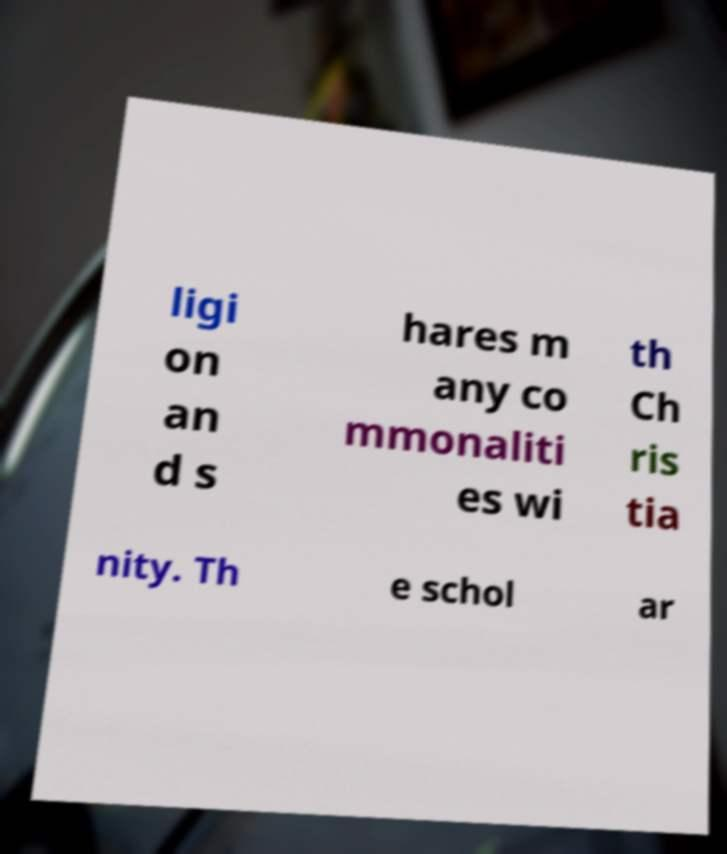Can you accurately transcribe the text from the provided image for me? ligi on an d s hares m any co mmonaliti es wi th Ch ris tia nity. Th e schol ar 